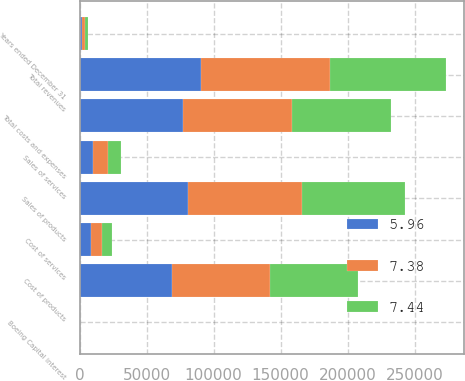Convert chart to OTSL. <chart><loc_0><loc_0><loc_500><loc_500><stacked_bar_chart><ecel><fcel>Years ended December 31<fcel>Sales of products<fcel>Sales of services<fcel>Total revenues<fcel>Cost of products<fcel>Cost of services<fcel>Boeing Capital interest<fcel>Total costs and expenses<nl><fcel>7.38<fcel>2015<fcel>85255<fcel>10859<fcel>96114<fcel>73446<fcel>8578<fcel>64<fcel>82088<nl><fcel>5.96<fcel>2014<fcel>80688<fcel>10074<fcel>90762<fcel>68551<fcel>8132<fcel>69<fcel>76752<nl><fcel>7.44<fcel>2013<fcel>76792<fcel>9831<fcel>86623<fcel>65640<fcel>7553<fcel>75<fcel>73268<nl></chart> 